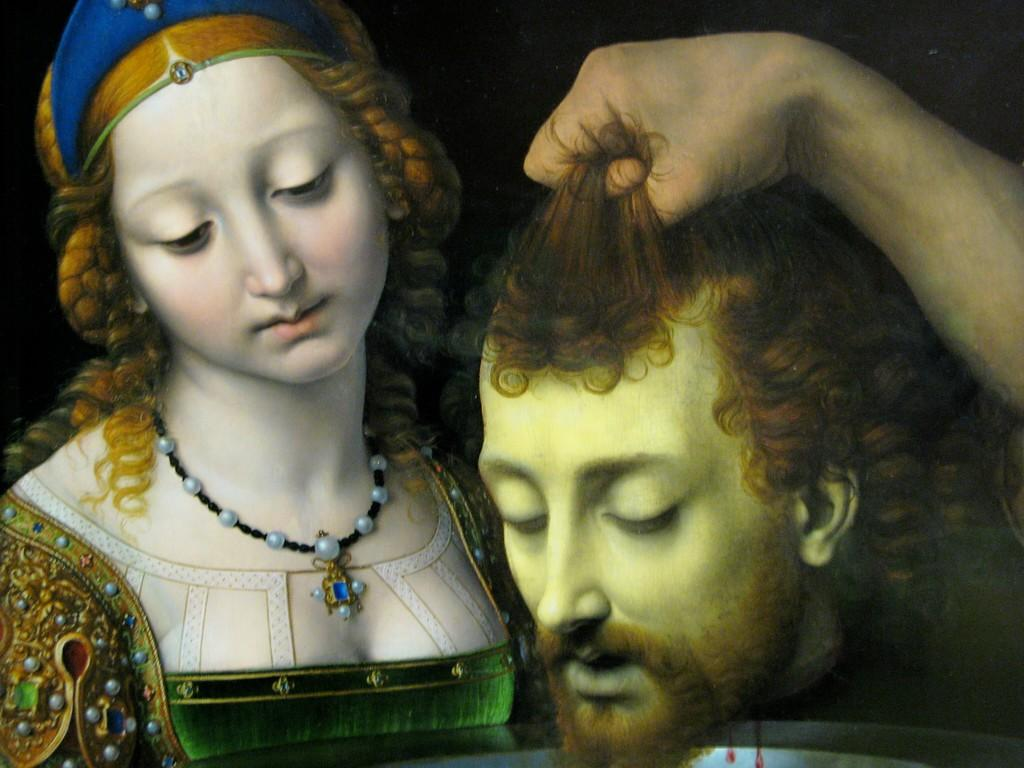What is the main subject of the image? There is a depiction of a woman in the image. Are there any other people depicted in the image? Yes, there is a depiction of a man's head in the image. What else can be seen on the right side of the image? There is a hand on the right side of the image. What type of bread is being used to swat the pest in the image? There is no bread or pest present in the image. How many visitors can be seen in the image? There are no visitors depicted in the image. 